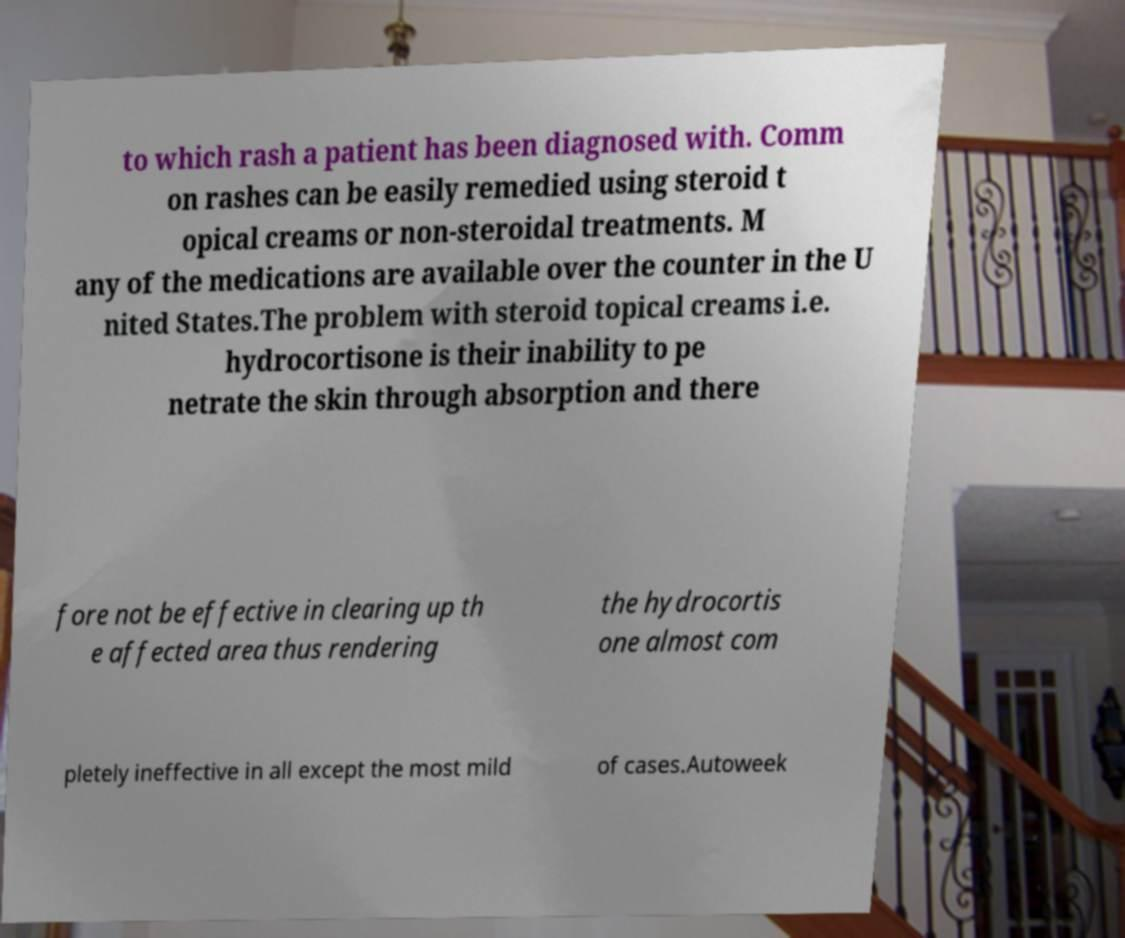I need the written content from this picture converted into text. Can you do that? to which rash a patient has been diagnosed with. Comm on rashes can be easily remedied using steroid t opical creams or non-steroidal treatments. M any of the medications are available over the counter in the U nited States.The problem with steroid topical creams i.e. hydrocortisone is their inability to pe netrate the skin through absorption and there fore not be effective in clearing up th e affected area thus rendering the hydrocortis one almost com pletely ineffective in all except the most mild of cases.Autoweek 